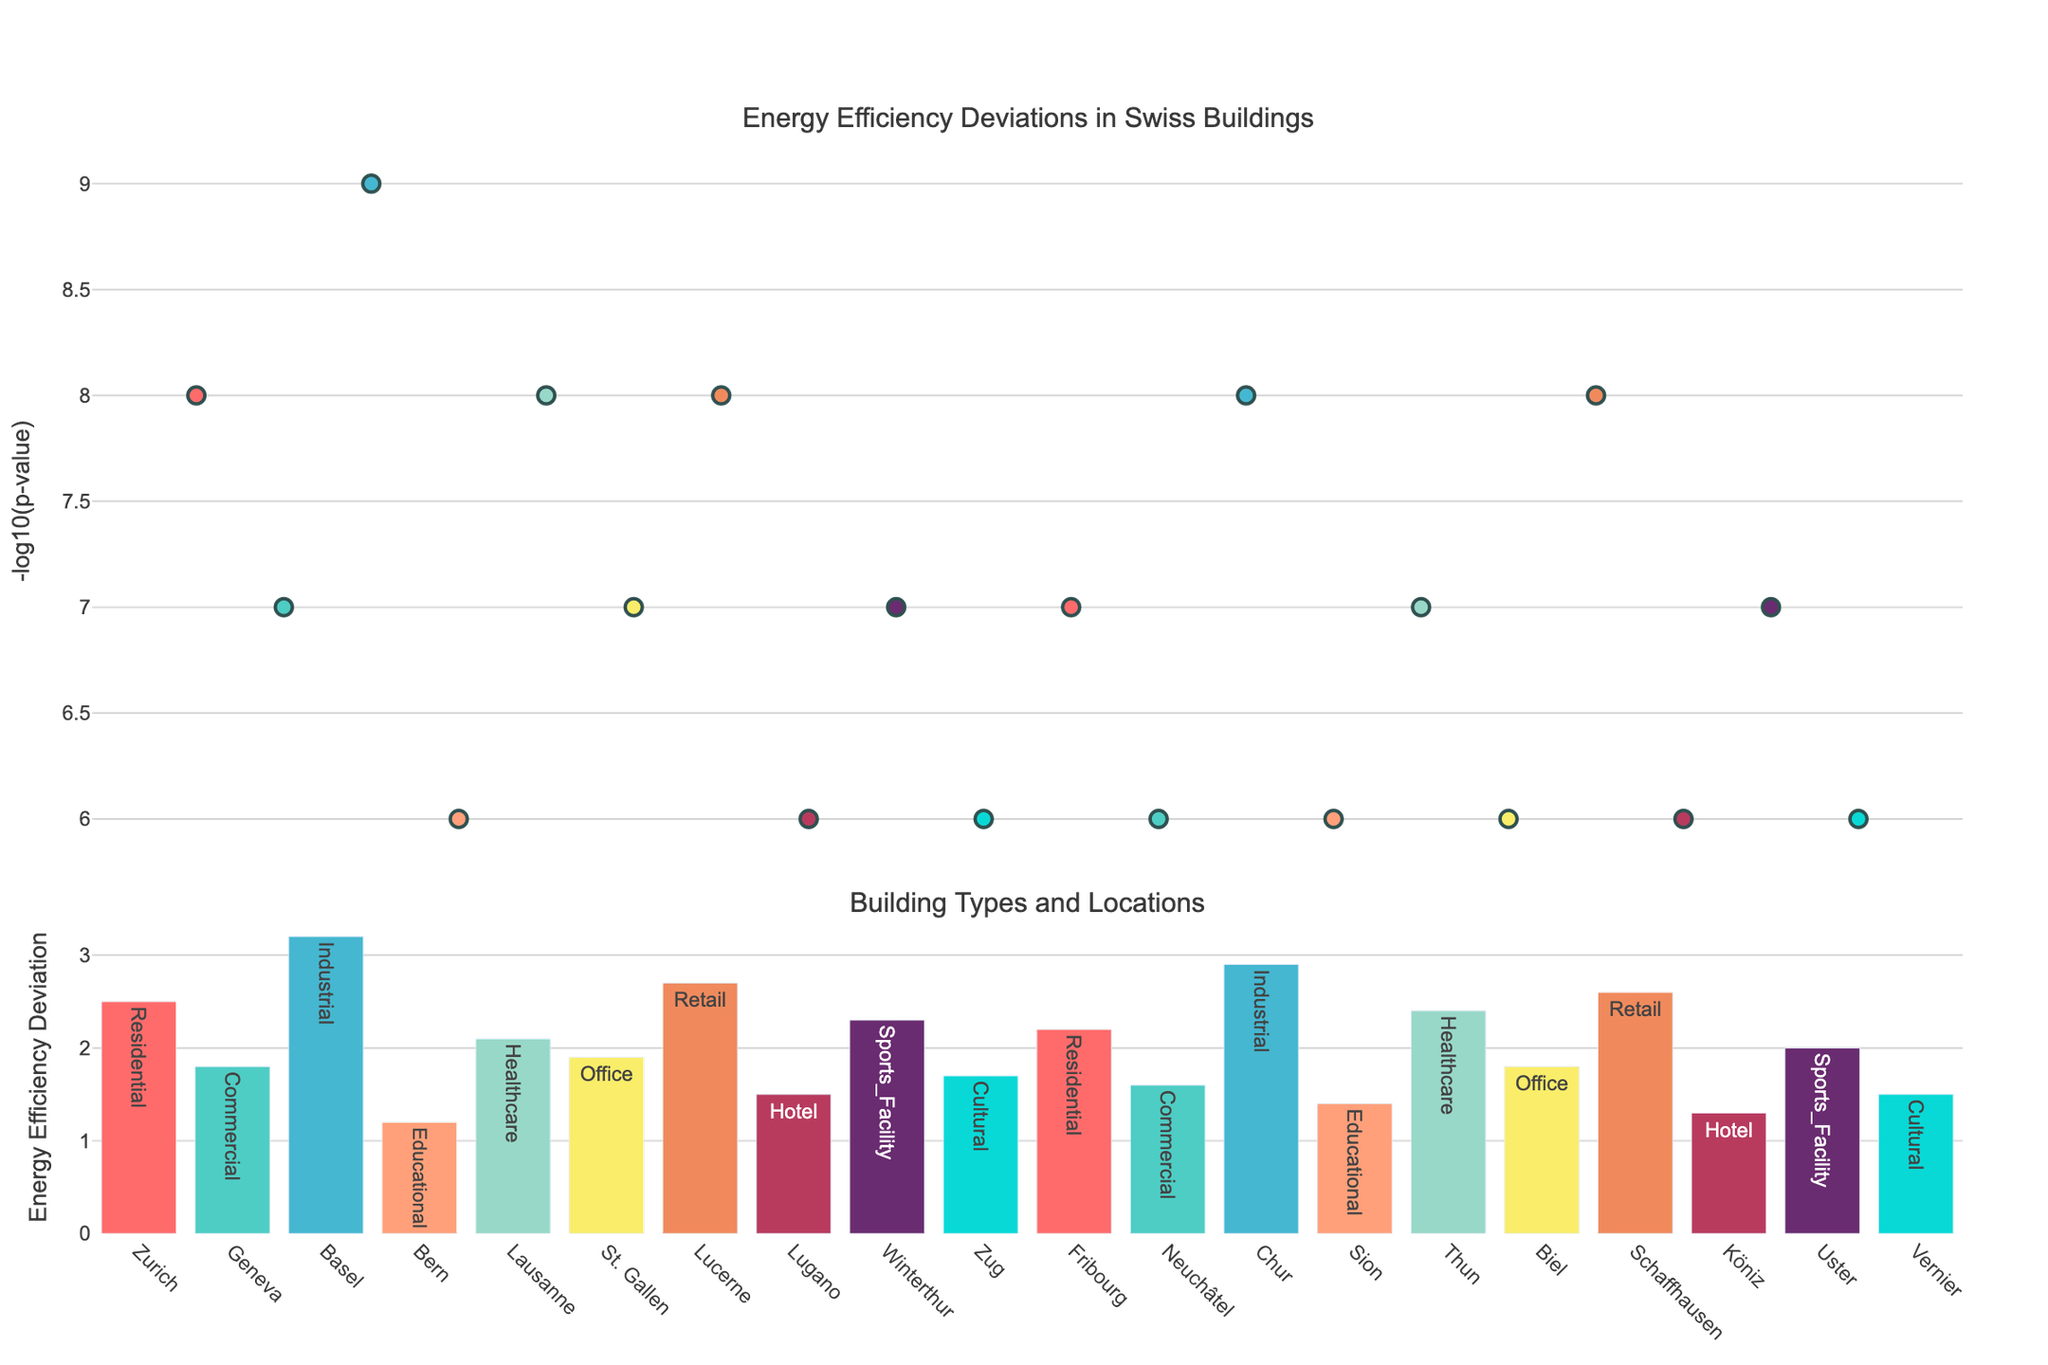What is the highest -log10(p-value) observed in the plot? To find the highest -log10(p-value), look at the topmost point in the scatter plot. The highest value is observed in Basel.
Answer: 9 Which building type shows the most significant deviation in energy efficiency in Basel? To determine the building type with the most significant deviation in energy efficiency in Basel, look at the associated bar plot. The energy efficiency deviation for Basel is 3.2. This corresponds to the "Industrial" building type.
Answer: Industrial How do the energy efficiency deviations of residential buildings in Zurich and Fribourg compare? To compare the energy efficiency deviations of residential buildings in Zurich and Fribourg, observe the heights of the corresponding bars in the bar plot. Zurich has a deviation of 2.5, and Fribourg has a deviation of 2.2. Therefore, Zurich's residential buildings have a higher deviation.
Answer: Zurich's is higher Which location has the lowest p-value and what is its building type? The lowest p-value corresponds to the highest -log10(p-value) in the scatter plot. This happens in Basel, which has an industrial building type.
Answer: Basel, Industrial Identify three locations with the highest energy efficiency deviations and their respective deviations. To find the highest energy efficiency deviations, look at the tallest bars in the bar plot. The three tallest bars correspond to Basel (3.2), Chur (2.9), and Lucerne (2.7).
Answer: Basel (3.2), Chur (2.9), Lucerne (2.7) What is the -log10(p-value) for the educational building in Bern? To find the -log10(p-value) for the educational building in Bern, look at the corresponding point in the scatter plot. The -log10(p-value) for Bern is 6.
Answer: 6 How does the energy efficiency deviation of commercial buildings in Geneva and Neuchâtel differ? Compare the heights of the bars for commercial buildings in Geneva and Neuchâtel. Geneva has a value of 1.8, and Neuchâtel has a value of 1.6.
Answer: Geneva's is higher What is the average -log10(p-value) of all points in the scatter plot? To calculate the average -log10(p-value), sum the values and divide by the number of points. The total sum of -log10(p-values) is 146, and there are 20 points, so the average is 146 / 20 = 7.3.
Answer: 7.3 Label the building types and locations with their corresponding energy efficiency deviations for Zurich, Geneva, and Basel. For Zurich: Residential, 2.5. For Geneva: Commercial, 1.8. For Basel: Industrial, 3.2.
Answer: Zurich: Residential (2.5), Geneva: Commercial (1.8), Basel: Industrial (3.2) In which location does the hotel building have the least energy efficiency deviation? Look for the bar corresponding to the hotel building type and compare the deviations. The lowest value is in Köniz with a deviation of 1.3.
Answer: Köniz 